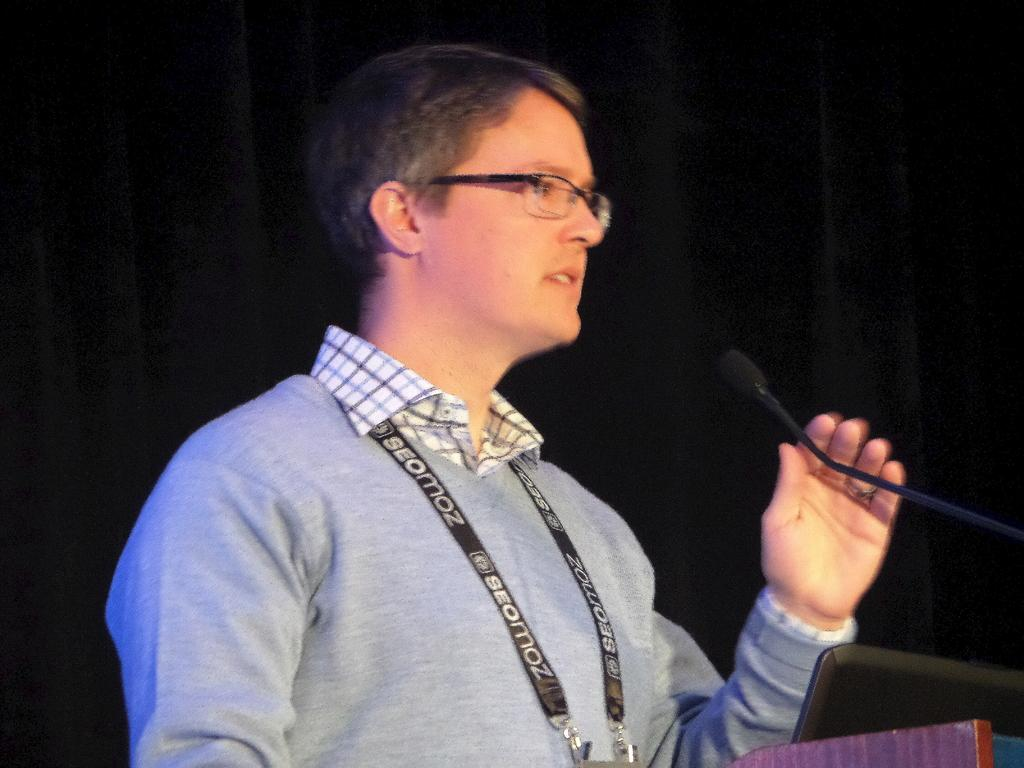Who is present in the image? There is a person in the image. What is the person holding in the image? The person is holding an id card and a microphone. Can you describe the person's appearance? The person is wearing glasses. What type of oranges can be seen in the image? There are no oranges present in the image. What kind of voyage is the person embarking on in the image? There is no indication of a voyage in the image. 